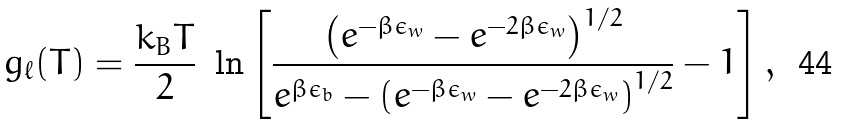Convert formula to latex. <formula><loc_0><loc_0><loc_500><loc_500>g _ { \ell } ( T ) = \frac { k _ { B } T } { 2 } \ \ln \left [ \frac { \left ( e ^ { - \beta \epsilon _ { w } } - e ^ { - 2 \beta \epsilon _ { w } } \right ) ^ { 1 / 2 } } { e ^ { \beta \epsilon _ { b } } - \left ( e ^ { - \beta \epsilon _ { w } } - e ^ { - 2 \beta \epsilon _ { w } } \right ) ^ { 1 / 2 } } - 1 \right ] ,</formula> 